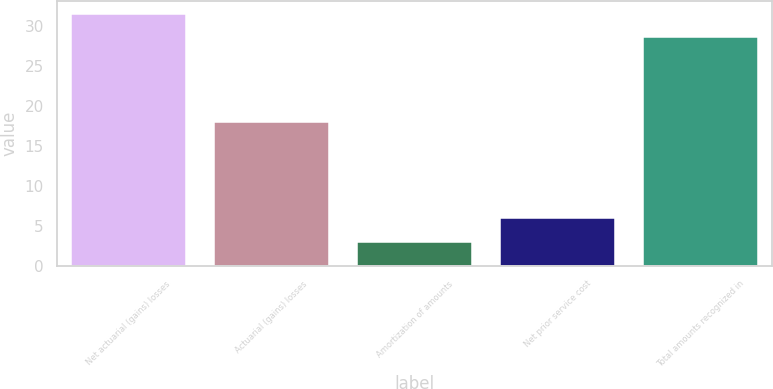Convert chart. <chart><loc_0><loc_0><loc_500><loc_500><bar_chart><fcel>Net actuarial (gains) losses<fcel>Actuarial (gains) losses<fcel>Amortization of amounts<fcel>Net prior service cost<fcel>Total amounts recognized in<nl><fcel>31.54<fcel>18.04<fcel>3.04<fcel>5.98<fcel>28.6<nl></chart> 